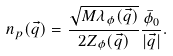Convert formula to latex. <formula><loc_0><loc_0><loc_500><loc_500>n _ { p } ( \vec { q } ) = \frac { \sqrt { M \lambda _ { \phi } ( \vec { q } ) } } { 2 Z _ { \phi } ( \vec { q } ) } \frac { \bar { \phi } _ { 0 } } { | \vec { q } | } .</formula> 